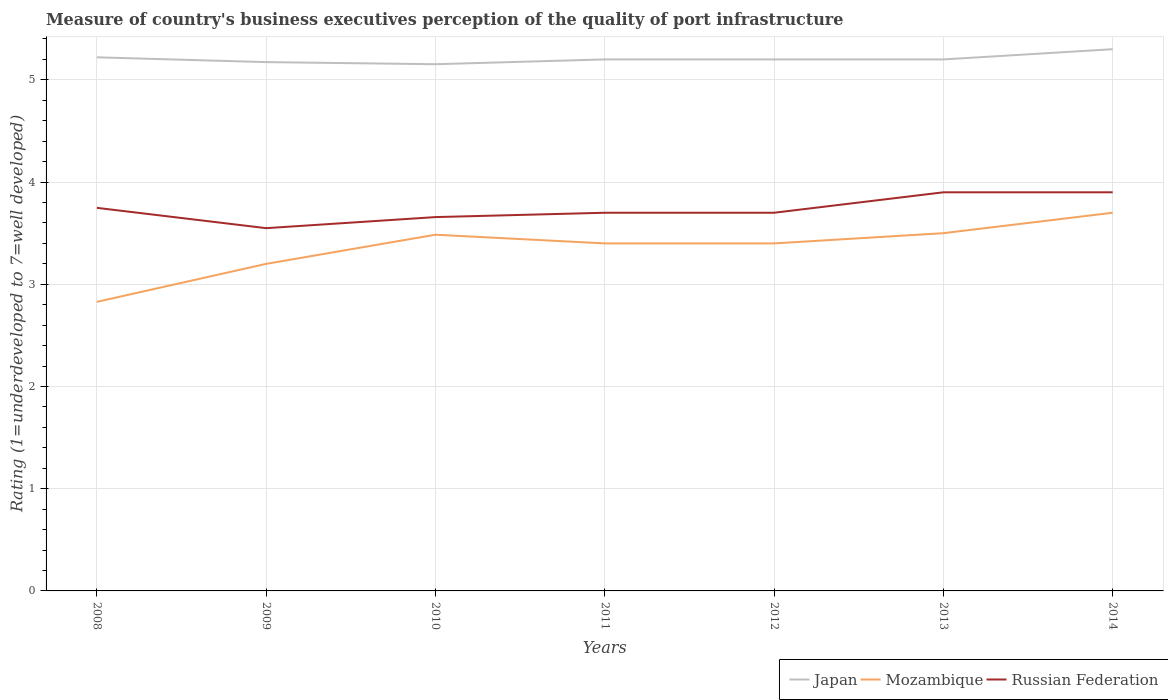How many different coloured lines are there?
Offer a very short reply. 3. Is the number of lines equal to the number of legend labels?
Provide a short and direct response. Yes. Across all years, what is the maximum ratings of the quality of port infrastructure in Mozambique?
Provide a short and direct response. 2.83. What is the total ratings of the quality of port infrastructure in Mozambique in the graph?
Provide a succinct answer. 0. What is the difference between the highest and the second highest ratings of the quality of port infrastructure in Mozambique?
Provide a short and direct response. 0.87. Is the ratings of the quality of port infrastructure in Russian Federation strictly greater than the ratings of the quality of port infrastructure in Japan over the years?
Keep it short and to the point. Yes. Are the values on the major ticks of Y-axis written in scientific E-notation?
Give a very brief answer. No. Does the graph contain any zero values?
Keep it short and to the point. No. Where does the legend appear in the graph?
Offer a terse response. Bottom right. How are the legend labels stacked?
Ensure brevity in your answer.  Horizontal. What is the title of the graph?
Ensure brevity in your answer.  Measure of country's business executives perception of the quality of port infrastructure. Does "Uganda" appear as one of the legend labels in the graph?
Offer a terse response. No. What is the label or title of the X-axis?
Give a very brief answer. Years. What is the label or title of the Y-axis?
Give a very brief answer. Rating (1=underdeveloped to 7=well developed). What is the Rating (1=underdeveloped to 7=well developed) in Japan in 2008?
Your response must be concise. 5.22. What is the Rating (1=underdeveloped to 7=well developed) in Mozambique in 2008?
Make the answer very short. 2.83. What is the Rating (1=underdeveloped to 7=well developed) in Russian Federation in 2008?
Offer a terse response. 3.75. What is the Rating (1=underdeveloped to 7=well developed) in Japan in 2009?
Your answer should be compact. 5.17. What is the Rating (1=underdeveloped to 7=well developed) in Mozambique in 2009?
Offer a terse response. 3.2. What is the Rating (1=underdeveloped to 7=well developed) of Russian Federation in 2009?
Give a very brief answer. 3.55. What is the Rating (1=underdeveloped to 7=well developed) of Japan in 2010?
Provide a short and direct response. 5.15. What is the Rating (1=underdeveloped to 7=well developed) of Mozambique in 2010?
Your response must be concise. 3.49. What is the Rating (1=underdeveloped to 7=well developed) of Russian Federation in 2010?
Your response must be concise. 3.66. What is the Rating (1=underdeveloped to 7=well developed) of Japan in 2011?
Offer a very short reply. 5.2. What is the Rating (1=underdeveloped to 7=well developed) in Russian Federation in 2011?
Give a very brief answer. 3.7. What is the Rating (1=underdeveloped to 7=well developed) of Russian Federation in 2012?
Ensure brevity in your answer.  3.7. What is the Rating (1=underdeveloped to 7=well developed) of Japan in 2013?
Ensure brevity in your answer.  5.2. What is the Rating (1=underdeveloped to 7=well developed) in Mozambique in 2013?
Give a very brief answer. 3.5. What is the Rating (1=underdeveloped to 7=well developed) in Japan in 2014?
Give a very brief answer. 5.3. What is the Rating (1=underdeveloped to 7=well developed) of Russian Federation in 2014?
Your answer should be very brief. 3.9. Across all years, what is the maximum Rating (1=underdeveloped to 7=well developed) in Japan?
Provide a short and direct response. 5.3. Across all years, what is the maximum Rating (1=underdeveloped to 7=well developed) of Russian Federation?
Offer a terse response. 3.9. Across all years, what is the minimum Rating (1=underdeveloped to 7=well developed) in Japan?
Make the answer very short. 5.15. Across all years, what is the minimum Rating (1=underdeveloped to 7=well developed) of Mozambique?
Provide a succinct answer. 2.83. Across all years, what is the minimum Rating (1=underdeveloped to 7=well developed) of Russian Federation?
Make the answer very short. 3.55. What is the total Rating (1=underdeveloped to 7=well developed) in Japan in the graph?
Your response must be concise. 36.45. What is the total Rating (1=underdeveloped to 7=well developed) in Mozambique in the graph?
Your response must be concise. 23.51. What is the total Rating (1=underdeveloped to 7=well developed) of Russian Federation in the graph?
Your response must be concise. 26.15. What is the difference between the Rating (1=underdeveloped to 7=well developed) in Japan in 2008 and that in 2009?
Give a very brief answer. 0.05. What is the difference between the Rating (1=underdeveloped to 7=well developed) in Mozambique in 2008 and that in 2009?
Your answer should be very brief. -0.37. What is the difference between the Rating (1=underdeveloped to 7=well developed) of Russian Federation in 2008 and that in 2009?
Make the answer very short. 0.2. What is the difference between the Rating (1=underdeveloped to 7=well developed) of Japan in 2008 and that in 2010?
Keep it short and to the point. 0.07. What is the difference between the Rating (1=underdeveloped to 7=well developed) in Mozambique in 2008 and that in 2010?
Keep it short and to the point. -0.66. What is the difference between the Rating (1=underdeveloped to 7=well developed) in Russian Federation in 2008 and that in 2010?
Offer a very short reply. 0.09. What is the difference between the Rating (1=underdeveloped to 7=well developed) in Japan in 2008 and that in 2011?
Your answer should be very brief. 0.02. What is the difference between the Rating (1=underdeveloped to 7=well developed) of Mozambique in 2008 and that in 2011?
Your answer should be compact. -0.57. What is the difference between the Rating (1=underdeveloped to 7=well developed) in Russian Federation in 2008 and that in 2011?
Give a very brief answer. 0.05. What is the difference between the Rating (1=underdeveloped to 7=well developed) in Japan in 2008 and that in 2012?
Your answer should be compact. 0.02. What is the difference between the Rating (1=underdeveloped to 7=well developed) of Mozambique in 2008 and that in 2012?
Offer a terse response. -0.57. What is the difference between the Rating (1=underdeveloped to 7=well developed) of Russian Federation in 2008 and that in 2012?
Offer a very short reply. 0.05. What is the difference between the Rating (1=underdeveloped to 7=well developed) of Japan in 2008 and that in 2013?
Ensure brevity in your answer.  0.02. What is the difference between the Rating (1=underdeveloped to 7=well developed) of Mozambique in 2008 and that in 2013?
Give a very brief answer. -0.67. What is the difference between the Rating (1=underdeveloped to 7=well developed) in Russian Federation in 2008 and that in 2013?
Offer a terse response. -0.15. What is the difference between the Rating (1=underdeveloped to 7=well developed) of Japan in 2008 and that in 2014?
Make the answer very short. -0.08. What is the difference between the Rating (1=underdeveloped to 7=well developed) of Mozambique in 2008 and that in 2014?
Provide a short and direct response. -0.87. What is the difference between the Rating (1=underdeveloped to 7=well developed) in Russian Federation in 2008 and that in 2014?
Provide a short and direct response. -0.15. What is the difference between the Rating (1=underdeveloped to 7=well developed) in Japan in 2009 and that in 2010?
Provide a short and direct response. 0.02. What is the difference between the Rating (1=underdeveloped to 7=well developed) of Mozambique in 2009 and that in 2010?
Provide a short and direct response. -0.29. What is the difference between the Rating (1=underdeveloped to 7=well developed) of Russian Federation in 2009 and that in 2010?
Offer a terse response. -0.11. What is the difference between the Rating (1=underdeveloped to 7=well developed) of Japan in 2009 and that in 2011?
Provide a succinct answer. -0.03. What is the difference between the Rating (1=underdeveloped to 7=well developed) of Mozambique in 2009 and that in 2011?
Keep it short and to the point. -0.2. What is the difference between the Rating (1=underdeveloped to 7=well developed) of Russian Federation in 2009 and that in 2011?
Provide a short and direct response. -0.15. What is the difference between the Rating (1=underdeveloped to 7=well developed) in Japan in 2009 and that in 2012?
Keep it short and to the point. -0.03. What is the difference between the Rating (1=underdeveloped to 7=well developed) in Mozambique in 2009 and that in 2012?
Keep it short and to the point. -0.2. What is the difference between the Rating (1=underdeveloped to 7=well developed) in Russian Federation in 2009 and that in 2012?
Make the answer very short. -0.15. What is the difference between the Rating (1=underdeveloped to 7=well developed) of Japan in 2009 and that in 2013?
Offer a very short reply. -0.03. What is the difference between the Rating (1=underdeveloped to 7=well developed) of Mozambique in 2009 and that in 2013?
Offer a terse response. -0.3. What is the difference between the Rating (1=underdeveloped to 7=well developed) of Russian Federation in 2009 and that in 2013?
Provide a succinct answer. -0.35. What is the difference between the Rating (1=underdeveloped to 7=well developed) of Japan in 2009 and that in 2014?
Make the answer very short. -0.13. What is the difference between the Rating (1=underdeveloped to 7=well developed) of Mozambique in 2009 and that in 2014?
Provide a succinct answer. -0.5. What is the difference between the Rating (1=underdeveloped to 7=well developed) of Russian Federation in 2009 and that in 2014?
Your answer should be very brief. -0.35. What is the difference between the Rating (1=underdeveloped to 7=well developed) in Japan in 2010 and that in 2011?
Your answer should be compact. -0.05. What is the difference between the Rating (1=underdeveloped to 7=well developed) of Mozambique in 2010 and that in 2011?
Offer a terse response. 0.09. What is the difference between the Rating (1=underdeveloped to 7=well developed) of Russian Federation in 2010 and that in 2011?
Make the answer very short. -0.04. What is the difference between the Rating (1=underdeveloped to 7=well developed) in Japan in 2010 and that in 2012?
Your answer should be compact. -0.05. What is the difference between the Rating (1=underdeveloped to 7=well developed) of Mozambique in 2010 and that in 2012?
Provide a succinct answer. 0.09. What is the difference between the Rating (1=underdeveloped to 7=well developed) in Russian Federation in 2010 and that in 2012?
Keep it short and to the point. -0.04. What is the difference between the Rating (1=underdeveloped to 7=well developed) in Japan in 2010 and that in 2013?
Make the answer very short. -0.05. What is the difference between the Rating (1=underdeveloped to 7=well developed) of Mozambique in 2010 and that in 2013?
Provide a succinct answer. -0.01. What is the difference between the Rating (1=underdeveloped to 7=well developed) of Russian Federation in 2010 and that in 2013?
Provide a succinct answer. -0.24. What is the difference between the Rating (1=underdeveloped to 7=well developed) in Japan in 2010 and that in 2014?
Your response must be concise. -0.15. What is the difference between the Rating (1=underdeveloped to 7=well developed) in Mozambique in 2010 and that in 2014?
Make the answer very short. -0.21. What is the difference between the Rating (1=underdeveloped to 7=well developed) in Russian Federation in 2010 and that in 2014?
Ensure brevity in your answer.  -0.24. What is the difference between the Rating (1=underdeveloped to 7=well developed) of Japan in 2011 and that in 2012?
Your answer should be compact. 0. What is the difference between the Rating (1=underdeveloped to 7=well developed) of Russian Federation in 2011 and that in 2012?
Keep it short and to the point. 0. What is the difference between the Rating (1=underdeveloped to 7=well developed) in Mozambique in 2011 and that in 2013?
Your answer should be very brief. -0.1. What is the difference between the Rating (1=underdeveloped to 7=well developed) of Russian Federation in 2011 and that in 2013?
Offer a very short reply. -0.2. What is the difference between the Rating (1=underdeveloped to 7=well developed) of Japan in 2011 and that in 2014?
Your answer should be compact. -0.1. What is the difference between the Rating (1=underdeveloped to 7=well developed) of Mozambique in 2011 and that in 2014?
Your answer should be compact. -0.3. What is the difference between the Rating (1=underdeveloped to 7=well developed) in Russian Federation in 2011 and that in 2014?
Your answer should be very brief. -0.2. What is the difference between the Rating (1=underdeveloped to 7=well developed) in Japan in 2012 and that in 2013?
Your answer should be very brief. 0. What is the difference between the Rating (1=underdeveloped to 7=well developed) in Mozambique in 2012 and that in 2013?
Your response must be concise. -0.1. What is the difference between the Rating (1=underdeveloped to 7=well developed) of Russian Federation in 2012 and that in 2013?
Your response must be concise. -0.2. What is the difference between the Rating (1=underdeveloped to 7=well developed) in Japan in 2012 and that in 2014?
Provide a short and direct response. -0.1. What is the difference between the Rating (1=underdeveloped to 7=well developed) of Mozambique in 2012 and that in 2014?
Keep it short and to the point. -0.3. What is the difference between the Rating (1=underdeveloped to 7=well developed) of Mozambique in 2013 and that in 2014?
Your answer should be very brief. -0.2. What is the difference between the Rating (1=underdeveloped to 7=well developed) of Russian Federation in 2013 and that in 2014?
Provide a succinct answer. 0. What is the difference between the Rating (1=underdeveloped to 7=well developed) of Japan in 2008 and the Rating (1=underdeveloped to 7=well developed) of Mozambique in 2009?
Keep it short and to the point. 2.02. What is the difference between the Rating (1=underdeveloped to 7=well developed) of Japan in 2008 and the Rating (1=underdeveloped to 7=well developed) of Russian Federation in 2009?
Provide a succinct answer. 1.67. What is the difference between the Rating (1=underdeveloped to 7=well developed) of Mozambique in 2008 and the Rating (1=underdeveloped to 7=well developed) of Russian Federation in 2009?
Provide a short and direct response. -0.72. What is the difference between the Rating (1=underdeveloped to 7=well developed) of Japan in 2008 and the Rating (1=underdeveloped to 7=well developed) of Mozambique in 2010?
Provide a short and direct response. 1.74. What is the difference between the Rating (1=underdeveloped to 7=well developed) in Japan in 2008 and the Rating (1=underdeveloped to 7=well developed) in Russian Federation in 2010?
Give a very brief answer. 1.56. What is the difference between the Rating (1=underdeveloped to 7=well developed) of Mozambique in 2008 and the Rating (1=underdeveloped to 7=well developed) of Russian Federation in 2010?
Provide a succinct answer. -0.83. What is the difference between the Rating (1=underdeveloped to 7=well developed) in Japan in 2008 and the Rating (1=underdeveloped to 7=well developed) in Mozambique in 2011?
Ensure brevity in your answer.  1.82. What is the difference between the Rating (1=underdeveloped to 7=well developed) of Japan in 2008 and the Rating (1=underdeveloped to 7=well developed) of Russian Federation in 2011?
Provide a succinct answer. 1.52. What is the difference between the Rating (1=underdeveloped to 7=well developed) in Mozambique in 2008 and the Rating (1=underdeveloped to 7=well developed) in Russian Federation in 2011?
Your answer should be very brief. -0.87. What is the difference between the Rating (1=underdeveloped to 7=well developed) in Japan in 2008 and the Rating (1=underdeveloped to 7=well developed) in Mozambique in 2012?
Give a very brief answer. 1.82. What is the difference between the Rating (1=underdeveloped to 7=well developed) in Japan in 2008 and the Rating (1=underdeveloped to 7=well developed) in Russian Federation in 2012?
Provide a short and direct response. 1.52. What is the difference between the Rating (1=underdeveloped to 7=well developed) of Mozambique in 2008 and the Rating (1=underdeveloped to 7=well developed) of Russian Federation in 2012?
Your answer should be very brief. -0.87. What is the difference between the Rating (1=underdeveloped to 7=well developed) in Japan in 2008 and the Rating (1=underdeveloped to 7=well developed) in Mozambique in 2013?
Keep it short and to the point. 1.72. What is the difference between the Rating (1=underdeveloped to 7=well developed) of Japan in 2008 and the Rating (1=underdeveloped to 7=well developed) of Russian Federation in 2013?
Give a very brief answer. 1.32. What is the difference between the Rating (1=underdeveloped to 7=well developed) in Mozambique in 2008 and the Rating (1=underdeveloped to 7=well developed) in Russian Federation in 2013?
Provide a short and direct response. -1.07. What is the difference between the Rating (1=underdeveloped to 7=well developed) in Japan in 2008 and the Rating (1=underdeveloped to 7=well developed) in Mozambique in 2014?
Offer a very short reply. 1.52. What is the difference between the Rating (1=underdeveloped to 7=well developed) of Japan in 2008 and the Rating (1=underdeveloped to 7=well developed) of Russian Federation in 2014?
Your answer should be very brief. 1.32. What is the difference between the Rating (1=underdeveloped to 7=well developed) of Mozambique in 2008 and the Rating (1=underdeveloped to 7=well developed) of Russian Federation in 2014?
Provide a succinct answer. -1.07. What is the difference between the Rating (1=underdeveloped to 7=well developed) of Japan in 2009 and the Rating (1=underdeveloped to 7=well developed) of Mozambique in 2010?
Provide a succinct answer. 1.69. What is the difference between the Rating (1=underdeveloped to 7=well developed) of Japan in 2009 and the Rating (1=underdeveloped to 7=well developed) of Russian Federation in 2010?
Provide a short and direct response. 1.52. What is the difference between the Rating (1=underdeveloped to 7=well developed) of Mozambique in 2009 and the Rating (1=underdeveloped to 7=well developed) of Russian Federation in 2010?
Your response must be concise. -0.46. What is the difference between the Rating (1=underdeveloped to 7=well developed) in Japan in 2009 and the Rating (1=underdeveloped to 7=well developed) in Mozambique in 2011?
Provide a short and direct response. 1.77. What is the difference between the Rating (1=underdeveloped to 7=well developed) of Japan in 2009 and the Rating (1=underdeveloped to 7=well developed) of Russian Federation in 2011?
Provide a short and direct response. 1.47. What is the difference between the Rating (1=underdeveloped to 7=well developed) of Mozambique in 2009 and the Rating (1=underdeveloped to 7=well developed) of Russian Federation in 2011?
Your answer should be very brief. -0.5. What is the difference between the Rating (1=underdeveloped to 7=well developed) of Japan in 2009 and the Rating (1=underdeveloped to 7=well developed) of Mozambique in 2012?
Provide a short and direct response. 1.77. What is the difference between the Rating (1=underdeveloped to 7=well developed) in Japan in 2009 and the Rating (1=underdeveloped to 7=well developed) in Russian Federation in 2012?
Provide a short and direct response. 1.47. What is the difference between the Rating (1=underdeveloped to 7=well developed) of Mozambique in 2009 and the Rating (1=underdeveloped to 7=well developed) of Russian Federation in 2012?
Your response must be concise. -0.5. What is the difference between the Rating (1=underdeveloped to 7=well developed) in Japan in 2009 and the Rating (1=underdeveloped to 7=well developed) in Mozambique in 2013?
Offer a terse response. 1.67. What is the difference between the Rating (1=underdeveloped to 7=well developed) of Japan in 2009 and the Rating (1=underdeveloped to 7=well developed) of Russian Federation in 2013?
Provide a succinct answer. 1.27. What is the difference between the Rating (1=underdeveloped to 7=well developed) in Mozambique in 2009 and the Rating (1=underdeveloped to 7=well developed) in Russian Federation in 2013?
Your response must be concise. -0.7. What is the difference between the Rating (1=underdeveloped to 7=well developed) in Japan in 2009 and the Rating (1=underdeveloped to 7=well developed) in Mozambique in 2014?
Make the answer very short. 1.47. What is the difference between the Rating (1=underdeveloped to 7=well developed) in Japan in 2009 and the Rating (1=underdeveloped to 7=well developed) in Russian Federation in 2014?
Provide a short and direct response. 1.27. What is the difference between the Rating (1=underdeveloped to 7=well developed) in Mozambique in 2009 and the Rating (1=underdeveloped to 7=well developed) in Russian Federation in 2014?
Offer a terse response. -0.7. What is the difference between the Rating (1=underdeveloped to 7=well developed) in Japan in 2010 and the Rating (1=underdeveloped to 7=well developed) in Mozambique in 2011?
Your answer should be very brief. 1.75. What is the difference between the Rating (1=underdeveloped to 7=well developed) of Japan in 2010 and the Rating (1=underdeveloped to 7=well developed) of Russian Federation in 2011?
Give a very brief answer. 1.45. What is the difference between the Rating (1=underdeveloped to 7=well developed) of Mozambique in 2010 and the Rating (1=underdeveloped to 7=well developed) of Russian Federation in 2011?
Ensure brevity in your answer.  -0.21. What is the difference between the Rating (1=underdeveloped to 7=well developed) of Japan in 2010 and the Rating (1=underdeveloped to 7=well developed) of Mozambique in 2012?
Provide a short and direct response. 1.75. What is the difference between the Rating (1=underdeveloped to 7=well developed) in Japan in 2010 and the Rating (1=underdeveloped to 7=well developed) in Russian Federation in 2012?
Offer a very short reply. 1.45. What is the difference between the Rating (1=underdeveloped to 7=well developed) of Mozambique in 2010 and the Rating (1=underdeveloped to 7=well developed) of Russian Federation in 2012?
Provide a succinct answer. -0.21. What is the difference between the Rating (1=underdeveloped to 7=well developed) in Japan in 2010 and the Rating (1=underdeveloped to 7=well developed) in Mozambique in 2013?
Your answer should be compact. 1.65. What is the difference between the Rating (1=underdeveloped to 7=well developed) of Japan in 2010 and the Rating (1=underdeveloped to 7=well developed) of Russian Federation in 2013?
Provide a short and direct response. 1.25. What is the difference between the Rating (1=underdeveloped to 7=well developed) of Mozambique in 2010 and the Rating (1=underdeveloped to 7=well developed) of Russian Federation in 2013?
Provide a succinct answer. -0.41. What is the difference between the Rating (1=underdeveloped to 7=well developed) in Japan in 2010 and the Rating (1=underdeveloped to 7=well developed) in Mozambique in 2014?
Your response must be concise. 1.45. What is the difference between the Rating (1=underdeveloped to 7=well developed) in Japan in 2010 and the Rating (1=underdeveloped to 7=well developed) in Russian Federation in 2014?
Offer a terse response. 1.25. What is the difference between the Rating (1=underdeveloped to 7=well developed) of Mozambique in 2010 and the Rating (1=underdeveloped to 7=well developed) of Russian Federation in 2014?
Your answer should be very brief. -0.41. What is the difference between the Rating (1=underdeveloped to 7=well developed) of Japan in 2011 and the Rating (1=underdeveloped to 7=well developed) of Mozambique in 2012?
Give a very brief answer. 1.8. What is the difference between the Rating (1=underdeveloped to 7=well developed) of Japan in 2011 and the Rating (1=underdeveloped to 7=well developed) of Russian Federation in 2012?
Provide a succinct answer. 1.5. What is the difference between the Rating (1=underdeveloped to 7=well developed) in Japan in 2011 and the Rating (1=underdeveloped to 7=well developed) in Mozambique in 2013?
Provide a succinct answer. 1.7. What is the difference between the Rating (1=underdeveloped to 7=well developed) in Japan in 2012 and the Rating (1=underdeveloped to 7=well developed) in Mozambique in 2013?
Your response must be concise. 1.7. What is the difference between the Rating (1=underdeveloped to 7=well developed) in Japan in 2012 and the Rating (1=underdeveloped to 7=well developed) in Russian Federation in 2013?
Provide a short and direct response. 1.3. What is the difference between the Rating (1=underdeveloped to 7=well developed) of Mozambique in 2012 and the Rating (1=underdeveloped to 7=well developed) of Russian Federation in 2014?
Give a very brief answer. -0.5. What is the difference between the Rating (1=underdeveloped to 7=well developed) in Japan in 2013 and the Rating (1=underdeveloped to 7=well developed) in Mozambique in 2014?
Your answer should be very brief. 1.5. What is the difference between the Rating (1=underdeveloped to 7=well developed) of Japan in 2013 and the Rating (1=underdeveloped to 7=well developed) of Russian Federation in 2014?
Keep it short and to the point. 1.3. What is the difference between the Rating (1=underdeveloped to 7=well developed) in Mozambique in 2013 and the Rating (1=underdeveloped to 7=well developed) in Russian Federation in 2014?
Your answer should be very brief. -0.4. What is the average Rating (1=underdeveloped to 7=well developed) in Japan per year?
Provide a succinct answer. 5.21. What is the average Rating (1=underdeveloped to 7=well developed) of Mozambique per year?
Keep it short and to the point. 3.36. What is the average Rating (1=underdeveloped to 7=well developed) in Russian Federation per year?
Your answer should be very brief. 3.74. In the year 2008, what is the difference between the Rating (1=underdeveloped to 7=well developed) in Japan and Rating (1=underdeveloped to 7=well developed) in Mozambique?
Provide a succinct answer. 2.39. In the year 2008, what is the difference between the Rating (1=underdeveloped to 7=well developed) of Japan and Rating (1=underdeveloped to 7=well developed) of Russian Federation?
Your response must be concise. 1.47. In the year 2008, what is the difference between the Rating (1=underdeveloped to 7=well developed) in Mozambique and Rating (1=underdeveloped to 7=well developed) in Russian Federation?
Your answer should be very brief. -0.92. In the year 2009, what is the difference between the Rating (1=underdeveloped to 7=well developed) of Japan and Rating (1=underdeveloped to 7=well developed) of Mozambique?
Your answer should be very brief. 1.97. In the year 2009, what is the difference between the Rating (1=underdeveloped to 7=well developed) of Japan and Rating (1=underdeveloped to 7=well developed) of Russian Federation?
Make the answer very short. 1.62. In the year 2009, what is the difference between the Rating (1=underdeveloped to 7=well developed) of Mozambique and Rating (1=underdeveloped to 7=well developed) of Russian Federation?
Provide a short and direct response. -0.35. In the year 2010, what is the difference between the Rating (1=underdeveloped to 7=well developed) of Japan and Rating (1=underdeveloped to 7=well developed) of Mozambique?
Keep it short and to the point. 1.67. In the year 2010, what is the difference between the Rating (1=underdeveloped to 7=well developed) in Japan and Rating (1=underdeveloped to 7=well developed) in Russian Federation?
Keep it short and to the point. 1.5. In the year 2010, what is the difference between the Rating (1=underdeveloped to 7=well developed) of Mozambique and Rating (1=underdeveloped to 7=well developed) of Russian Federation?
Provide a succinct answer. -0.17. In the year 2011, what is the difference between the Rating (1=underdeveloped to 7=well developed) in Japan and Rating (1=underdeveloped to 7=well developed) in Russian Federation?
Make the answer very short. 1.5. In the year 2012, what is the difference between the Rating (1=underdeveloped to 7=well developed) of Japan and Rating (1=underdeveloped to 7=well developed) of Russian Federation?
Ensure brevity in your answer.  1.5. In the year 2012, what is the difference between the Rating (1=underdeveloped to 7=well developed) in Mozambique and Rating (1=underdeveloped to 7=well developed) in Russian Federation?
Provide a short and direct response. -0.3. In the year 2013, what is the difference between the Rating (1=underdeveloped to 7=well developed) in Japan and Rating (1=underdeveloped to 7=well developed) in Mozambique?
Offer a terse response. 1.7. In the year 2013, what is the difference between the Rating (1=underdeveloped to 7=well developed) of Mozambique and Rating (1=underdeveloped to 7=well developed) of Russian Federation?
Give a very brief answer. -0.4. In the year 2014, what is the difference between the Rating (1=underdeveloped to 7=well developed) in Japan and Rating (1=underdeveloped to 7=well developed) in Mozambique?
Your answer should be very brief. 1.6. In the year 2014, what is the difference between the Rating (1=underdeveloped to 7=well developed) of Japan and Rating (1=underdeveloped to 7=well developed) of Russian Federation?
Ensure brevity in your answer.  1.4. What is the ratio of the Rating (1=underdeveloped to 7=well developed) in Japan in 2008 to that in 2009?
Your response must be concise. 1.01. What is the ratio of the Rating (1=underdeveloped to 7=well developed) of Mozambique in 2008 to that in 2009?
Provide a short and direct response. 0.88. What is the ratio of the Rating (1=underdeveloped to 7=well developed) in Russian Federation in 2008 to that in 2009?
Keep it short and to the point. 1.06. What is the ratio of the Rating (1=underdeveloped to 7=well developed) of Japan in 2008 to that in 2010?
Your response must be concise. 1.01. What is the ratio of the Rating (1=underdeveloped to 7=well developed) in Mozambique in 2008 to that in 2010?
Offer a terse response. 0.81. What is the ratio of the Rating (1=underdeveloped to 7=well developed) in Russian Federation in 2008 to that in 2010?
Provide a succinct answer. 1.02. What is the ratio of the Rating (1=underdeveloped to 7=well developed) in Mozambique in 2008 to that in 2011?
Your answer should be very brief. 0.83. What is the ratio of the Rating (1=underdeveloped to 7=well developed) in Mozambique in 2008 to that in 2012?
Your answer should be very brief. 0.83. What is the ratio of the Rating (1=underdeveloped to 7=well developed) in Russian Federation in 2008 to that in 2012?
Your answer should be compact. 1.01. What is the ratio of the Rating (1=underdeveloped to 7=well developed) of Mozambique in 2008 to that in 2013?
Your response must be concise. 0.81. What is the ratio of the Rating (1=underdeveloped to 7=well developed) in Russian Federation in 2008 to that in 2013?
Provide a succinct answer. 0.96. What is the ratio of the Rating (1=underdeveloped to 7=well developed) of Japan in 2008 to that in 2014?
Your response must be concise. 0.98. What is the ratio of the Rating (1=underdeveloped to 7=well developed) of Mozambique in 2008 to that in 2014?
Your answer should be very brief. 0.76. What is the ratio of the Rating (1=underdeveloped to 7=well developed) in Japan in 2009 to that in 2010?
Provide a short and direct response. 1. What is the ratio of the Rating (1=underdeveloped to 7=well developed) of Mozambique in 2009 to that in 2010?
Your answer should be very brief. 0.92. What is the ratio of the Rating (1=underdeveloped to 7=well developed) of Russian Federation in 2009 to that in 2010?
Keep it short and to the point. 0.97. What is the ratio of the Rating (1=underdeveloped to 7=well developed) in Japan in 2009 to that in 2011?
Keep it short and to the point. 0.99. What is the ratio of the Rating (1=underdeveloped to 7=well developed) in Mozambique in 2009 to that in 2011?
Keep it short and to the point. 0.94. What is the ratio of the Rating (1=underdeveloped to 7=well developed) in Russian Federation in 2009 to that in 2011?
Keep it short and to the point. 0.96. What is the ratio of the Rating (1=underdeveloped to 7=well developed) of Japan in 2009 to that in 2012?
Offer a very short reply. 0.99. What is the ratio of the Rating (1=underdeveloped to 7=well developed) of Mozambique in 2009 to that in 2012?
Your answer should be very brief. 0.94. What is the ratio of the Rating (1=underdeveloped to 7=well developed) in Russian Federation in 2009 to that in 2012?
Provide a short and direct response. 0.96. What is the ratio of the Rating (1=underdeveloped to 7=well developed) in Japan in 2009 to that in 2013?
Offer a terse response. 0.99. What is the ratio of the Rating (1=underdeveloped to 7=well developed) in Mozambique in 2009 to that in 2013?
Make the answer very short. 0.91. What is the ratio of the Rating (1=underdeveloped to 7=well developed) in Russian Federation in 2009 to that in 2013?
Offer a very short reply. 0.91. What is the ratio of the Rating (1=underdeveloped to 7=well developed) in Japan in 2009 to that in 2014?
Provide a short and direct response. 0.98. What is the ratio of the Rating (1=underdeveloped to 7=well developed) of Mozambique in 2009 to that in 2014?
Your response must be concise. 0.86. What is the ratio of the Rating (1=underdeveloped to 7=well developed) of Russian Federation in 2009 to that in 2014?
Give a very brief answer. 0.91. What is the ratio of the Rating (1=underdeveloped to 7=well developed) of Japan in 2010 to that in 2011?
Keep it short and to the point. 0.99. What is the ratio of the Rating (1=underdeveloped to 7=well developed) of Mozambique in 2010 to that in 2011?
Provide a short and direct response. 1.02. What is the ratio of the Rating (1=underdeveloped to 7=well developed) of Japan in 2010 to that in 2012?
Offer a terse response. 0.99. What is the ratio of the Rating (1=underdeveloped to 7=well developed) of Japan in 2010 to that in 2013?
Give a very brief answer. 0.99. What is the ratio of the Rating (1=underdeveloped to 7=well developed) of Mozambique in 2010 to that in 2013?
Provide a short and direct response. 1. What is the ratio of the Rating (1=underdeveloped to 7=well developed) in Russian Federation in 2010 to that in 2013?
Make the answer very short. 0.94. What is the ratio of the Rating (1=underdeveloped to 7=well developed) in Japan in 2010 to that in 2014?
Your answer should be very brief. 0.97. What is the ratio of the Rating (1=underdeveloped to 7=well developed) in Mozambique in 2010 to that in 2014?
Your answer should be compact. 0.94. What is the ratio of the Rating (1=underdeveloped to 7=well developed) of Russian Federation in 2010 to that in 2014?
Offer a very short reply. 0.94. What is the ratio of the Rating (1=underdeveloped to 7=well developed) of Japan in 2011 to that in 2012?
Your answer should be very brief. 1. What is the ratio of the Rating (1=underdeveloped to 7=well developed) in Mozambique in 2011 to that in 2013?
Ensure brevity in your answer.  0.97. What is the ratio of the Rating (1=underdeveloped to 7=well developed) of Russian Federation in 2011 to that in 2013?
Make the answer very short. 0.95. What is the ratio of the Rating (1=underdeveloped to 7=well developed) in Japan in 2011 to that in 2014?
Give a very brief answer. 0.98. What is the ratio of the Rating (1=underdeveloped to 7=well developed) in Mozambique in 2011 to that in 2014?
Provide a succinct answer. 0.92. What is the ratio of the Rating (1=underdeveloped to 7=well developed) in Russian Federation in 2011 to that in 2014?
Your answer should be very brief. 0.95. What is the ratio of the Rating (1=underdeveloped to 7=well developed) in Japan in 2012 to that in 2013?
Offer a very short reply. 1. What is the ratio of the Rating (1=underdeveloped to 7=well developed) in Mozambique in 2012 to that in 2013?
Offer a very short reply. 0.97. What is the ratio of the Rating (1=underdeveloped to 7=well developed) in Russian Federation in 2012 to that in 2013?
Your answer should be very brief. 0.95. What is the ratio of the Rating (1=underdeveloped to 7=well developed) in Japan in 2012 to that in 2014?
Give a very brief answer. 0.98. What is the ratio of the Rating (1=underdeveloped to 7=well developed) of Mozambique in 2012 to that in 2014?
Provide a succinct answer. 0.92. What is the ratio of the Rating (1=underdeveloped to 7=well developed) of Russian Federation in 2012 to that in 2014?
Give a very brief answer. 0.95. What is the ratio of the Rating (1=underdeveloped to 7=well developed) of Japan in 2013 to that in 2014?
Make the answer very short. 0.98. What is the ratio of the Rating (1=underdeveloped to 7=well developed) of Mozambique in 2013 to that in 2014?
Ensure brevity in your answer.  0.95. What is the ratio of the Rating (1=underdeveloped to 7=well developed) of Russian Federation in 2013 to that in 2014?
Offer a terse response. 1. What is the difference between the highest and the second highest Rating (1=underdeveloped to 7=well developed) in Japan?
Give a very brief answer. 0.08. What is the difference between the highest and the lowest Rating (1=underdeveloped to 7=well developed) in Japan?
Your response must be concise. 0.15. What is the difference between the highest and the lowest Rating (1=underdeveloped to 7=well developed) of Mozambique?
Ensure brevity in your answer.  0.87. What is the difference between the highest and the lowest Rating (1=underdeveloped to 7=well developed) in Russian Federation?
Give a very brief answer. 0.35. 